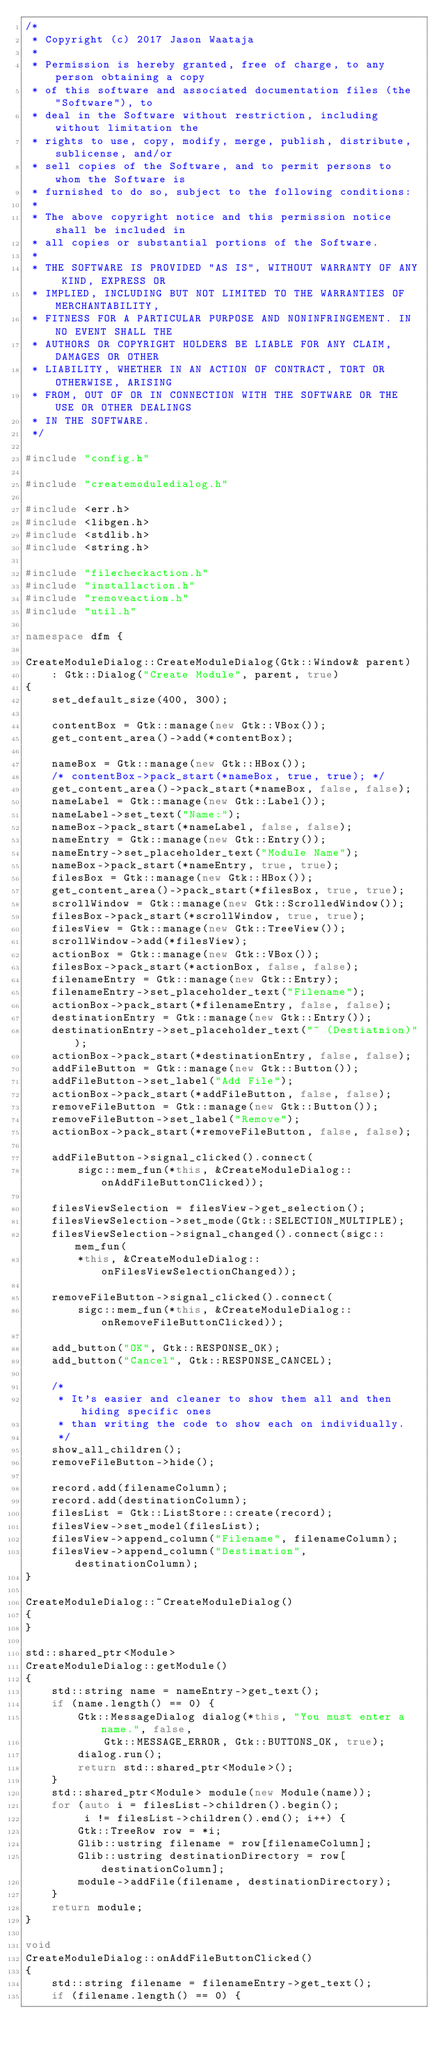<code> <loc_0><loc_0><loc_500><loc_500><_C++_>/*
 * Copyright (c) 2017 Jason Waataja
 *
 * Permission is hereby granted, free of charge, to any person obtaining a copy
 * of this software and associated documentation files (the "Software"), to
 * deal in the Software without restriction, including without limitation the
 * rights to use, copy, modify, merge, publish, distribute, sublicense, and/or
 * sell copies of the Software, and to permit persons to whom the Software is
 * furnished to do so, subject to the following conditions:
 *
 * The above copyright notice and this permission notice shall be included in
 * all copies or substantial portions of the Software.
 *
 * THE SOFTWARE IS PROVIDED "AS IS", WITHOUT WARRANTY OF ANY KIND, EXPRESS OR
 * IMPLIED, INCLUDING BUT NOT LIMITED TO THE WARRANTIES OF MERCHANTABILITY,
 * FITNESS FOR A PARTICULAR PURPOSE AND NONINFRINGEMENT. IN NO EVENT SHALL THE
 * AUTHORS OR COPYRIGHT HOLDERS BE LIABLE FOR ANY CLAIM, DAMAGES OR OTHER
 * LIABILITY, WHETHER IN AN ACTION OF CONTRACT, TORT OR OTHERWISE, ARISING
 * FROM, OUT OF OR IN CONNECTION WITH THE SOFTWARE OR THE USE OR OTHER DEALINGS
 * IN THE SOFTWARE.
 */

#include "config.h"

#include "createmoduledialog.h"

#include <err.h>
#include <libgen.h>
#include <stdlib.h>
#include <string.h>

#include "filecheckaction.h"
#include "installaction.h"
#include "removeaction.h"
#include "util.h"

namespace dfm {

CreateModuleDialog::CreateModuleDialog(Gtk::Window& parent)
    : Gtk::Dialog("Create Module", parent, true)
{
    set_default_size(400, 300);

    contentBox = Gtk::manage(new Gtk::VBox());
    get_content_area()->add(*contentBox);

    nameBox = Gtk::manage(new Gtk::HBox());
    /* contentBox->pack_start(*nameBox, true, true); */
    get_content_area()->pack_start(*nameBox, false, false);
    nameLabel = Gtk::manage(new Gtk::Label());
    nameLabel->set_text("Name:");
    nameBox->pack_start(*nameLabel, false, false);
    nameEntry = Gtk::manage(new Gtk::Entry());
    nameEntry->set_placeholder_text("Module Name");
    nameBox->pack_start(*nameEntry, true, true);
    filesBox = Gtk::manage(new Gtk::HBox());
    get_content_area()->pack_start(*filesBox, true, true);
    scrollWindow = Gtk::manage(new Gtk::ScrolledWindow());
    filesBox->pack_start(*scrollWindow, true, true);
    filesView = Gtk::manage(new Gtk::TreeView());
    scrollWindow->add(*filesView);
    actionBox = Gtk::manage(new Gtk::VBox());
    filesBox->pack_start(*actionBox, false, false);
    filenameEntry = Gtk::manage(new Gtk::Entry);
    filenameEntry->set_placeholder_text("Filename");
    actionBox->pack_start(*filenameEntry, false, false);
    destinationEntry = Gtk::manage(new Gtk::Entry());
    destinationEntry->set_placeholder_text("~ (Destiatnion)");
    actionBox->pack_start(*destinationEntry, false, false);
    addFileButton = Gtk::manage(new Gtk::Button());
    addFileButton->set_label("Add File");
    actionBox->pack_start(*addFileButton, false, false);
    removeFileButton = Gtk::manage(new Gtk::Button());
    removeFileButton->set_label("Remove");
    actionBox->pack_start(*removeFileButton, false, false);

    addFileButton->signal_clicked().connect(
        sigc::mem_fun(*this, &CreateModuleDialog::onAddFileButtonClicked));

    filesViewSelection = filesView->get_selection();
    filesViewSelection->set_mode(Gtk::SELECTION_MULTIPLE);
    filesViewSelection->signal_changed().connect(sigc::mem_fun(
        *this, &CreateModuleDialog::onFilesViewSelectionChanged));

    removeFileButton->signal_clicked().connect(
        sigc::mem_fun(*this, &CreateModuleDialog::onRemoveFileButtonClicked));

    add_button("OK", Gtk::RESPONSE_OK);
    add_button("Cancel", Gtk::RESPONSE_CANCEL);

    /*
     * It's easier and cleaner to show them all and then hiding specific ones
     * than writing the code to show each on individually.
     */
    show_all_children();
    removeFileButton->hide();

    record.add(filenameColumn);
    record.add(destinationColumn);
    filesList = Gtk::ListStore::create(record);
    filesView->set_model(filesList);
    filesView->append_column("Filename", filenameColumn);
    filesView->append_column("Destination", destinationColumn);
}

CreateModuleDialog::~CreateModuleDialog()
{
}

std::shared_ptr<Module>
CreateModuleDialog::getModule()
{
    std::string name = nameEntry->get_text();
    if (name.length() == 0) {
        Gtk::MessageDialog dialog(*this, "You must enter a name.", false,
            Gtk::MESSAGE_ERROR, Gtk::BUTTONS_OK, true);
        dialog.run();
        return std::shared_ptr<Module>();
    }
    std::shared_ptr<Module> module(new Module(name));
    for (auto i = filesList->children().begin();
         i != filesList->children().end(); i++) {
        Gtk::TreeRow row = *i;
        Glib::ustring filename = row[filenameColumn];
        Glib::ustring destinationDirectory = row[destinationColumn];
        module->addFile(filename, destinationDirectory);
    }
    return module;
}

void
CreateModuleDialog::onAddFileButtonClicked()
{
    std::string filename = filenameEntry->get_text();
    if (filename.length() == 0) {</code> 